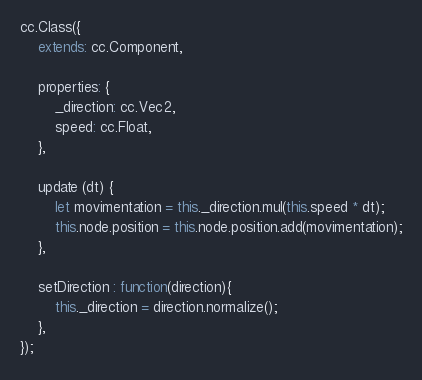Convert code to text. <code><loc_0><loc_0><loc_500><loc_500><_JavaScript_>cc.Class({
    extends: cc.Component,

    properties: {
        _direction: cc.Vec2,
        speed: cc.Float,
    },

    update (dt) {
        let movimentation = this._direction.mul(this.speed * dt);
        this.node.position = this.node.position.add(movimentation);
    },

    setDirection : function(direction){
        this._direction = direction.normalize();
    },
});
</code> 